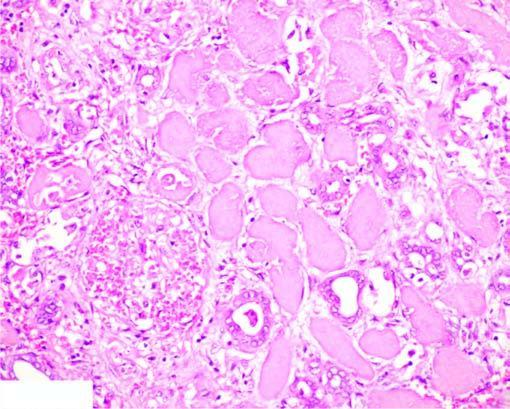does the affected area on right show cells with intensely eosinophilic cytoplasm of tubular cells?
Answer the question using a single word or phrase. Yes 